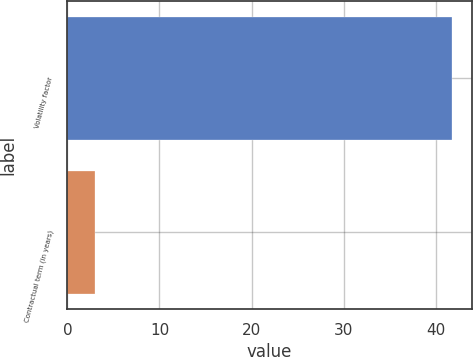Convert chart. <chart><loc_0><loc_0><loc_500><loc_500><bar_chart><fcel>Volatility factor<fcel>Contractual term (in years)<nl><fcel>41.8<fcel>3<nl></chart> 